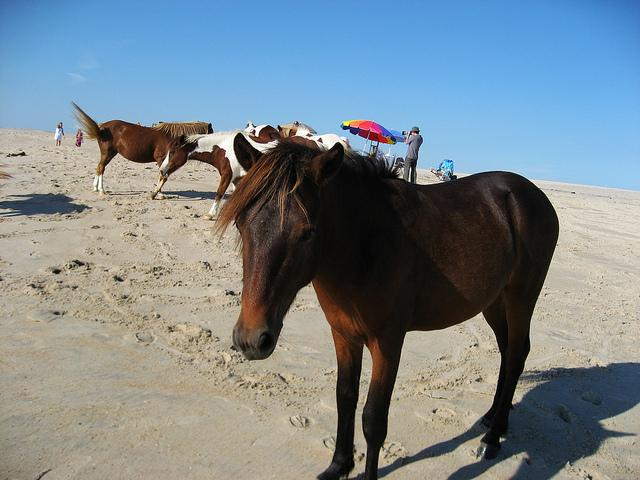How many horses are countable on the beach? five 